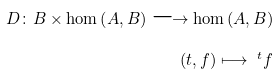<formula> <loc_0><loc_0><loc_500><loc_500>D \colon B \times \hom \left ( A , B \right ) \longrightarrow \hom \left ( A , B \right ) \\ \left ( t , f \right ) \longmapsto \ ^ { t } f</formula> 